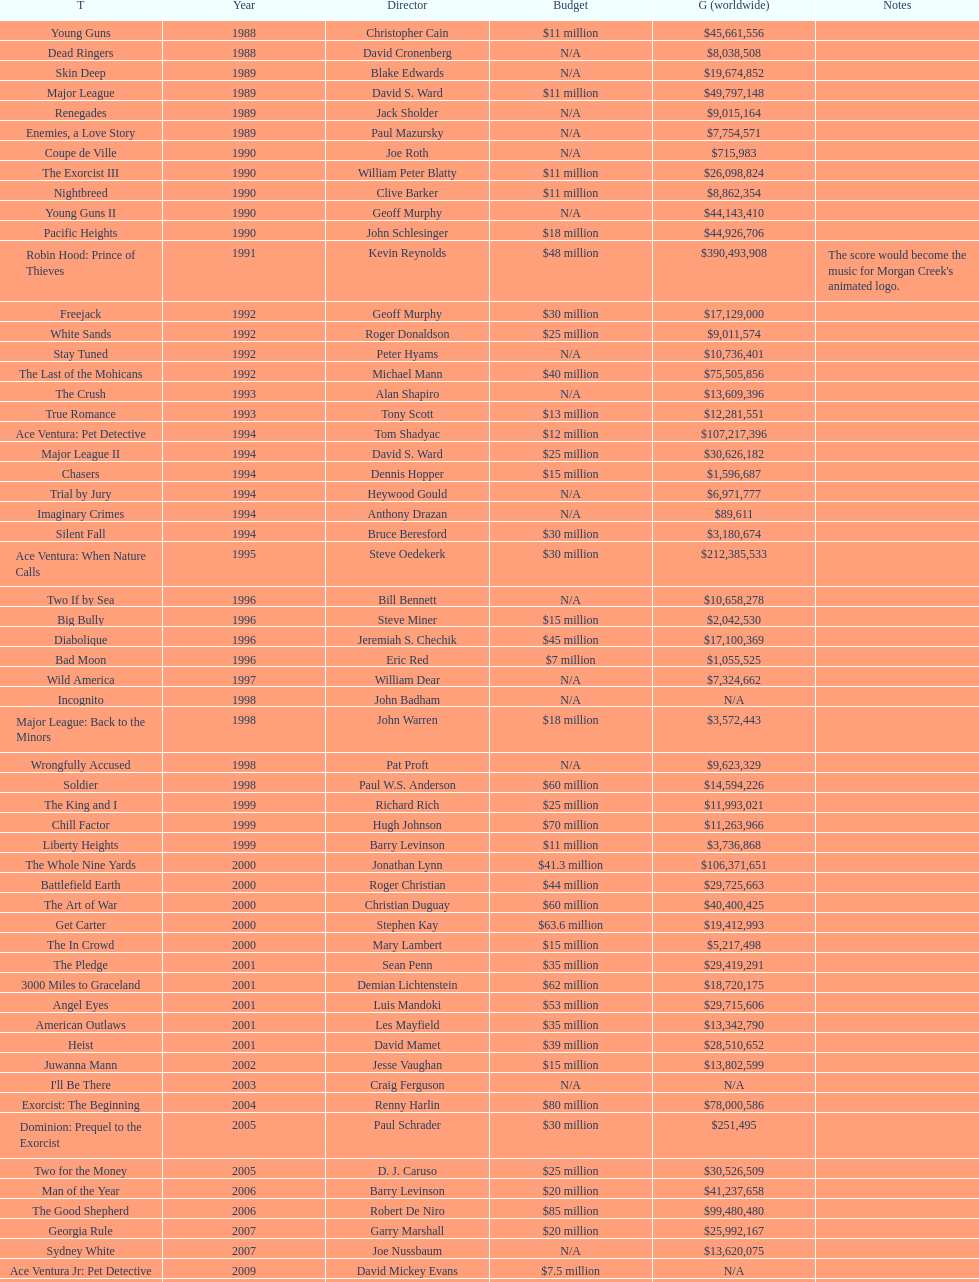What was the last movie morgan creek made for a budget under thirty million? Ace Ventura Jr: Pet Detective. 